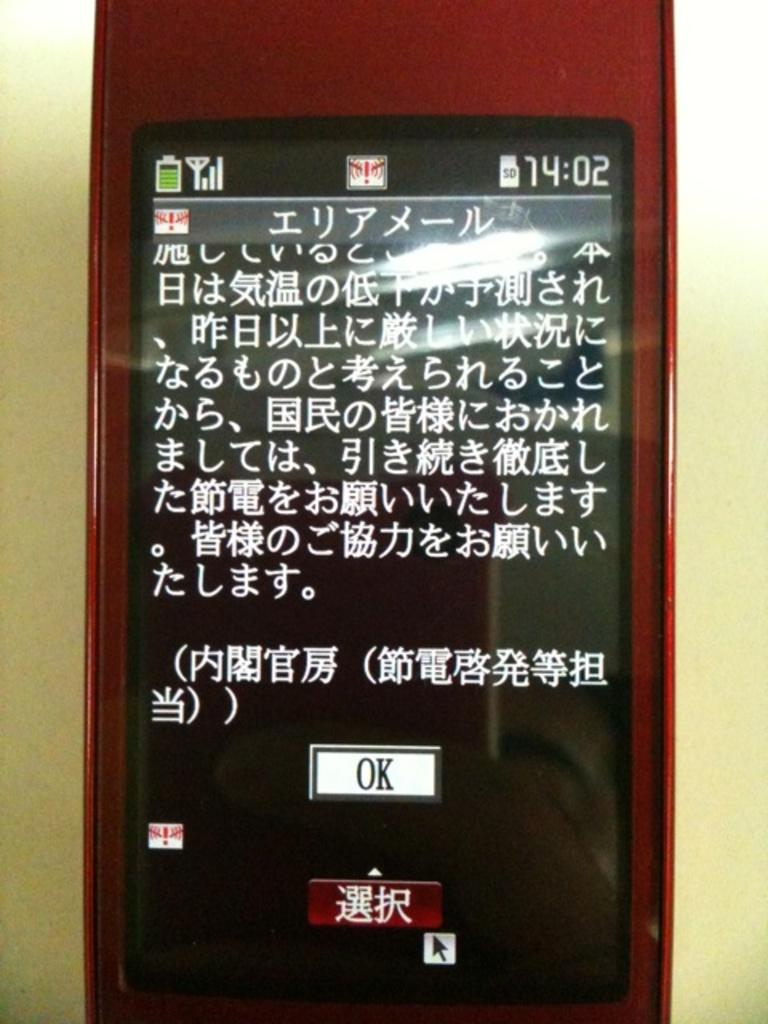<image>
Offer a succinct explanation of the picture presented. a red cell phone with a white button that says Ok 